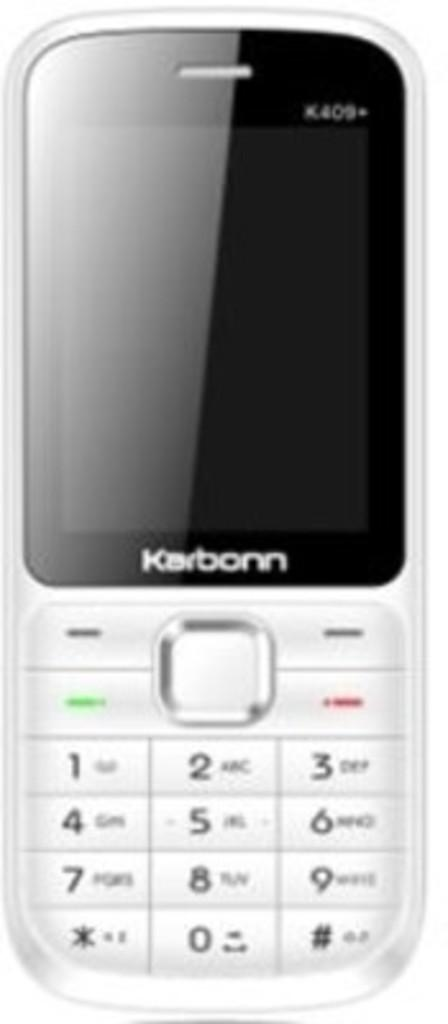<image>
Describe the image concisely. An older, Karborn cell phone with buttons that have numbers on them, rather than a touch screen is against a plain, white back ground. 